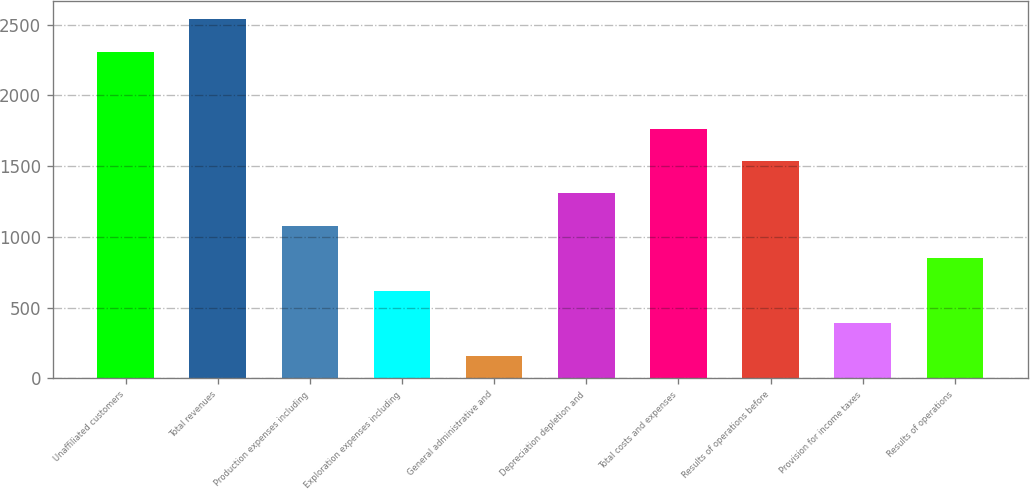Convert chart to OTSL. <chart><loc_0><loc_0><loc_500><loc_500><bar_chart><fcel>Unaffiliated customers<fcel>Total revenues<fcel>Production expenses including<fcel>Exploration expenses including<fcel>General administrative and<fcel>Depreciation depletion and<fcel>Total costs and expenses<fcel>Results of operations before<fcel>Provision for income taxes<fcel>Results of operations<nl><fcel>2310<fcel>2539.2<fcel>1077.8<fcel>619.4<fcel>161<fcel>1307<fcel>1765.4<fcel>1536.2<fcel>390.2<fcel>848.6<nl></chart> 